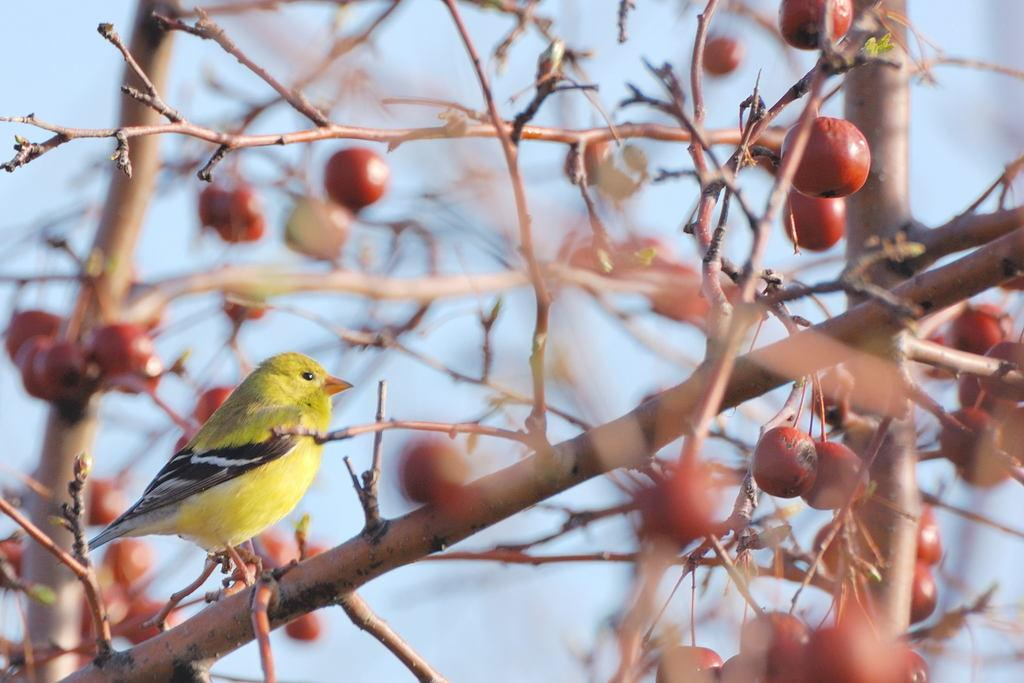What type of animal can be seen in the image? There is a bird in the image. What is hanging from the tree in the image? There are fruits hanging on a tree in the image. What level of belief does the bird have in the shoes in the image? There are no shoes present in the image, so it is not possible to determine the bird's level of belief in them. 